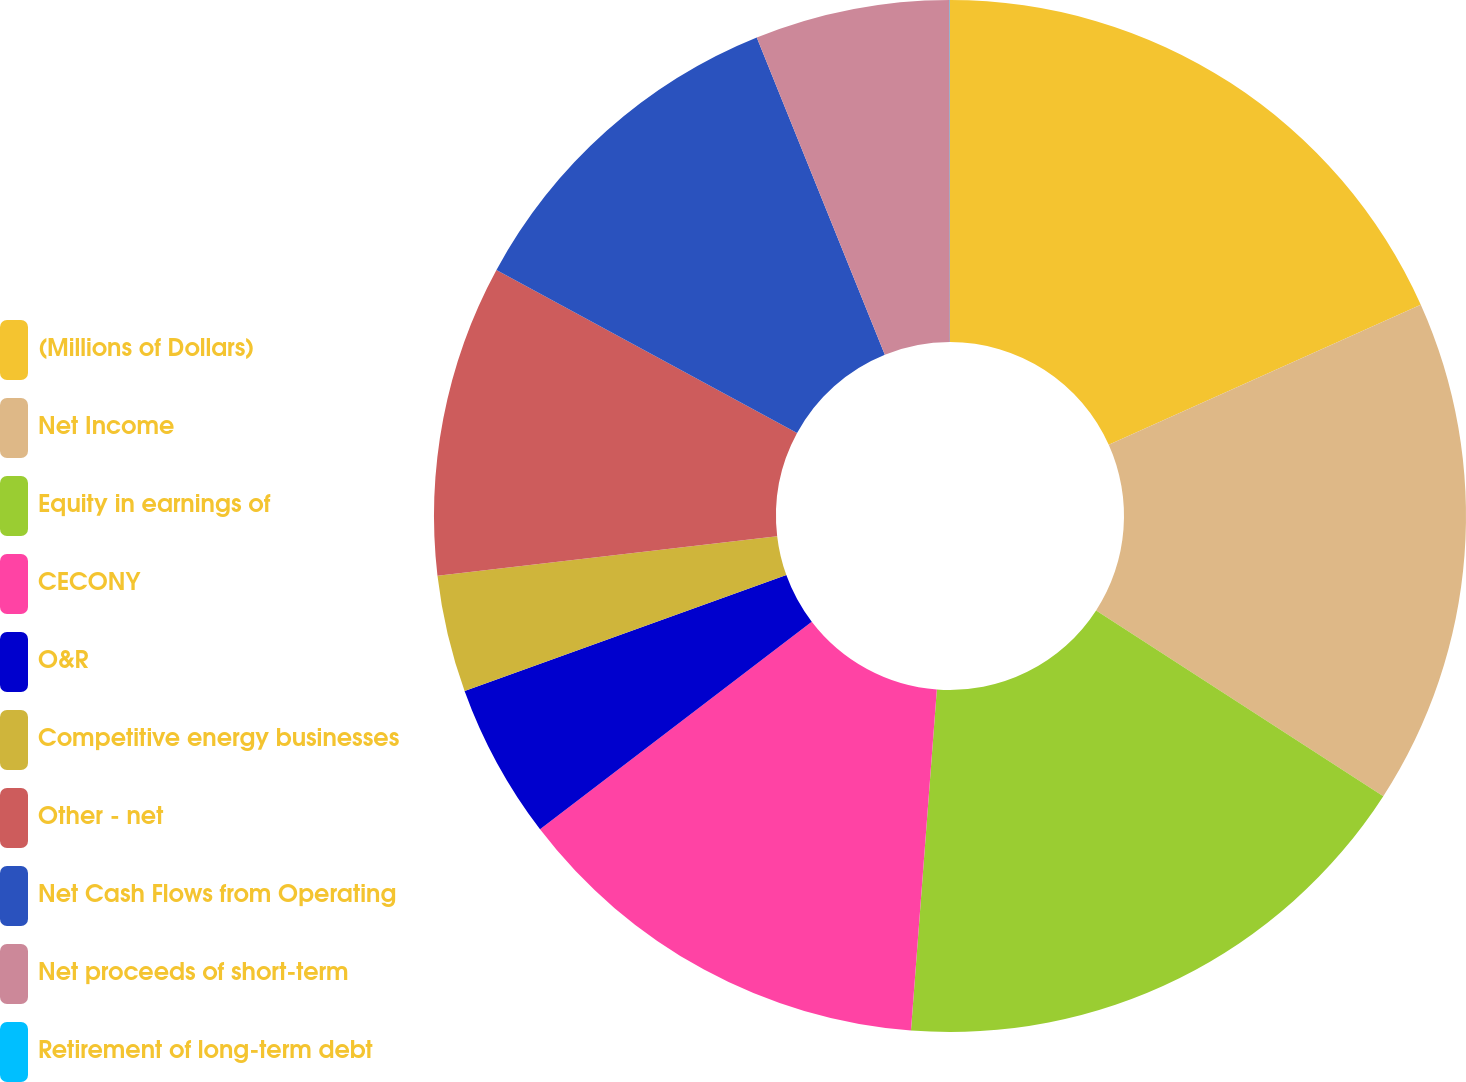Convert chart to OTSL. <chart><loc_0><loc_0><loc_500><loc_500><pie_chart><fcel>(Millions of Dollars)<fcel>Net Income<fcel>Equity in earnings of<fcel>CECONY<fcel>O&R<fcel>Competitive energy businesses<fcel>Other - net<fcel>Net Cash Flows from Operating<fcel>Net proceeds of short-term<fcel>Retirement of long-term debt<nl><fcel>18.29%<fcel>15.85%<fcel>17.07%<fcel>13.41%<fcel>4.88%<fcel>3.66%<fcel>9.76%<fcel>10.98%<fcel>6.1%<fcel>0.01%<nl></chart> 